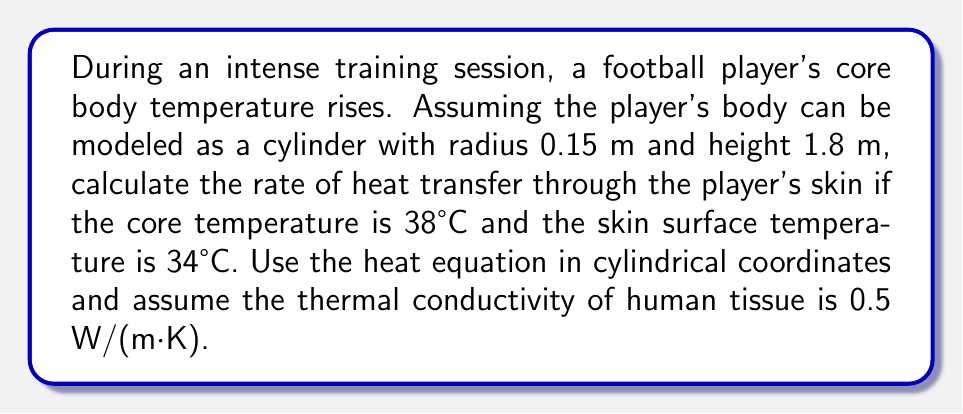Help me with this question. To solve this problem, we'll use the heat equation in cylindrical coordinates and apply steady-state conditions:

1) The general heat equation in cylindrical coordinates is:
   $$\frac{1}{r}\frac{\partial}{\partial r}\left(r\frac{\partial T}{\partial r}\right) + \frac{1}{r^2}\frac{\partial^2 T}{\partial \theta^2} + \frac{\partial^2 T}{\partial z^2} = \frac{1}{\alpha}\frac{\partial T}{\partial t}$$

2) Assuming steady-state and radial symmetry, this simplifies to:
   $$\frac{1}{r}\frac{d}{dr}\left(r\frac{dT}{dr}\right) = 0$$

3) The solution to this equation is:
   $$T(r) = C_1 \ln(r) + C_2$$

4) Apply boundary conditions:
   At $r = 0$ (core): $T(0) = 38°C$
   At $r = 0.15$ m (surface): $T(0.15) = 34°C$

5) Solving for constants:
   $C_2 = 38$ (since $\ln(0)$ is undefined)
   $34 = C_1 \ln(0.15) + 38$
   $C_1 = \frac{-4}{\ln(0.15)} \approx 2.1252$

6) The temperature distribution is:
   $$T(r) = 2.1252 \ln(r) + 38$$

7) The heat flux is given by Fourier's law:
   $$q = -k\frac{dT}{dr} = -k\frac{2.1252}{r}$$

8) The total heat transfer rate is:
   $$Q = -k\frac{dT}{dr}(2\pi rh) = -k(2.1252)(2\pi h) = -13.3619kh$$

9) Substituting values:
   $Q = -13.3619 \cdot 0.5 \cdot 1.8 = -12.0257$ W

The negative sign indicates heat flowing out of the body.
Answer: -12.03 W 